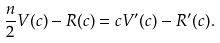Convert formula to latex. <formula><loc_0><loc_0><loc_500><loc_500>\frac { n } { 2 } V ( c ) - R ( c ) = c V ^ { \prime } ( c ) - R ^ { \prime } ( c ) .</formula> 